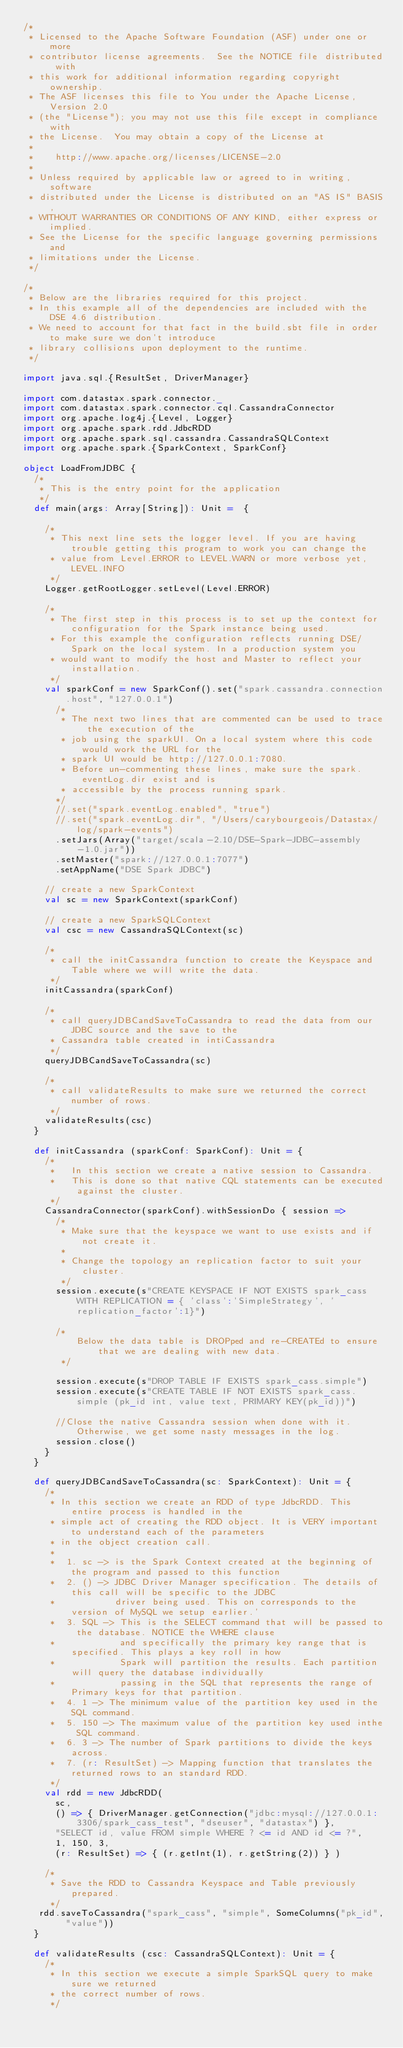<code> <loc_0><loc_0><loc_500><loc_500><_Scala_>/*
 * Licensed to the Apache Software Foundation (ASF) under one or more
 * contributor license agreements.  See the NOTICE file distributed with
 * this work for additional information regarding copyright ownership.
 * The ASF licenses this file to You under the Apache License, Version 2.0
 * (the "License"); you may not use this file except in compliance with
 * the License.  You may obtain a copy of the License at
 *
 *    http://www.apache.org/licenses/LICENSE-2.0
 *
 * Unless required by applicable law or agreed to in writing, software
 * distributed under the License is distributed on an "AS IS" BASIS,
 * WITHOUT WARRANTIES OR CONDITIONS OF ANY KIND, either express or implied.
 * See the License for the specific language governing permissions and
 * limitations under the License.
 */

/*
 * Below are the libraries required for this project.
 * In this example all of the dependencies are included with the DSE 4.6 distribution.
 * We need to account for that fact in the build.sbt file in order to make sure we don't introduce
 * library collisions upon deployment to the runtime.
 */

import java.sql.{ResultSet, DriverManager}

import com.datastax.spark.connector._
import com.datastax.spark.connector.cql.CassandraConnector
import org.apache.log4j.{Level, Logger}
import org.apache.spark.rdd.JdbcRDD
import org.apache.spark.sql.cassandra.CassandraSQLContext
import org.apache.spark.{SparkContext, SparkConf}

object LoadFromJDBC {
  /*
   * This is the entry point for the application
   */
  def main(args: Array[String]): Unit =  {

    /*
     * This next line sets the logger level. If you are having trouble getting this program to work you can change the
     * value from Level.ERROR to LEVEL.WARN or more verbose yet, LEVEL.INFO
     */
    Logger.getRootLogger.setLevel(Level.ERROR)

    /*
     * The first step in this process is to set up the context for configuration for the Spark instance being used.
     * For this example the configuration reflects running DSE/Spark on the local system. In a production system you
     * would want to modify the host and Master to reflect your installation.
     */
    val sparkConf = new SparkConf().set("spark.cassandra.connection.host", "127.0.0.1")
      /*
       * The next two lines that are commented can be used to trace the execution of the
       * job using the sparkUI. On a local system where this code would work the URL for the
       * spark UI would be http://127.0.0.1:7080.
       * Before un-commenting these lines, make sure the spark.eventLog.dir exist and is
       * accessible by the process running spark.
      */
      //.set("spark.eventLog.enabled", "true")
      //.set("spark.eventLog.dir", "/Users/carybourgeois/Datastax/log/spark-events")
      .setJars(Array("target/scala-2.10/DSE-Spark-JDBC-assembly-1.0.jar"))
      .setMaster("spark://127.0.0.1:7077")
      .setAppName("DSE Spark JDBC")

    // create a new SparkContext
    val sc = new SparkContext(sparkConf)

    // create a new SparkSQLContext
    val csc = new CassandraSQLContext(sc)

    /*
     * call the initCassandra function to create the Keyspace and Table where we will write the data.
     */
    initCassandra(sparkConf)

    /*
     * call queryJDBCandSaveToCassandra to read the data from our JDBC source and the save to the
     * Cassandra table created in intiCassandra
     */
    queryJDBCandSaveToCassandra(sc)

    /*
     * call validateResults to make sure we returned the correct number of rows.
     */
    validateResults(csc)
  }

  def initCassandra (sparkConf: SparkConf): Unit = {
    /*
     *   In this section we create a native session to Cassandra.
     *   This is done so that native CQL statements can be executed against the cluster.
     */
    CassandraConnector(sparkConf).withSessionDo { session =>
      /*
       * Make sure that the keyspace we want to use exists and if not create it.
       *
       * Change the topology an replication factor to suit your cluster.
       */
      session.execute(s"CREATE KEYSPACE IF NOT EXISTS spark_cass WITH REPLICATION = { 'class':'SimpleStrategy', 'replication_factor':1}")

      /*
          Below the data table is DROPped and re-CREATEd to ensure that we are dealing with new data.
       */

      session.execute(s"DROP TABLE IF EXISTS spark_cass.simple")
      session.execute(s"CREATE TABLE IF NOT EXISTS spark_cass.simple (pk_id int, value text, PRIMARY KEY(pk_id))")

      //Close the native Cassandra session when done with it. Otherwise, we get some nasty messages in the log.
      session.close()
    }
  }

  def queryJDBCandSaveToCassandra(sc: SparkContext): Unit = {
    /*
     * In this section we create an RDD of type JdbcRDD. This entire process is handled in the
     * simple act of creating the RDD object. It is VERY important to understand each of the parameters
     * in the object creation call.
     *
     *  1. sc -> is the Spark Context created at the beginning of the program and passed to this function
     *  2. () -> JDBC Driver Manager specification. The details of this call will be specific to the JDBC
     *           driver being used. This on corresponds to the version of MySQL we setup earlier.'
     *  3. SQL -> This is the SELECT command that will be passed to the database. NOTICE the WHERE clause
     *            and specifically the primary key range that is specified. This plays a key roll in how
     *            Spark will partition the results. Each partition will query the database individually
     *            passing in the SQL that represents the range of Primary keys for that partition.
     *  4. 1 -> The minimum value of the partition key used in the SQL command.
     *  5. 150 -> The maximum value of the partition key used inthe SQL command.
     *  6. 3 -> The number of Spark partitions to divide the keys across.
     *  7. (r: ResultSet) -> Mapping function that translates the returned rows to an standard RDD.
     */
    val rdd = new JdbcRDD(
      sc,
      () => { DriverManager.getConnection("jdbc:mysql://127.0.0.1:3306/spark_cass_test", "dseuser", "datastax") },
      "SELECT id, value FROM simple WHERE ? <= id AND id <= ?",
      1, 150, 3,
      (r: ResultSet) => { (r.getInt(1), r.getString(2)) } )

    /*
     * Save the RDD to Cassandra Keyspace and Table previously prepared.
     */
   rdd.saveToCassandra("spark_cass", "simple", SomeColumns("pk_id", "value"))
  }

  def validateResults (csc: CassandraSQLContext): Unit = {
    /*
     * In this section we execute a simple SparkSQL query to make sure we returned
     * the correct number of rows.
     */</code> 